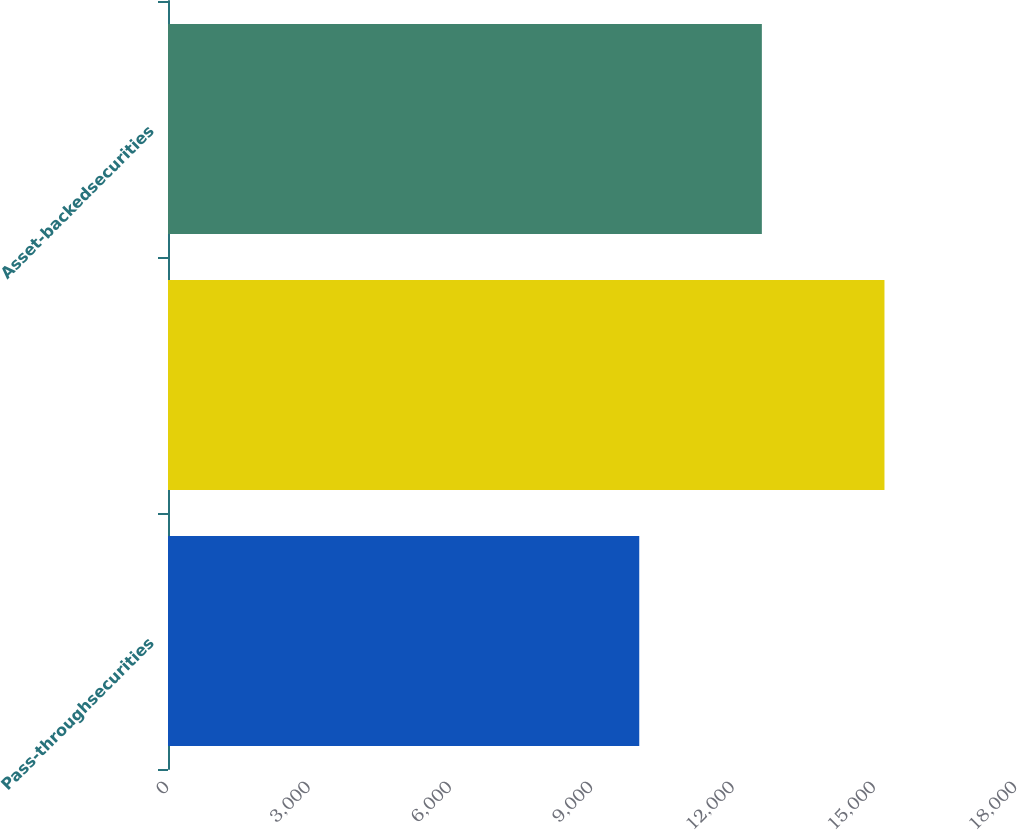Convert chart. <chart><loc_0><loc_0><loc_500><loc_500><bar_chart><fcel>Pass-throughsecurities<fcel>Unnamed: 1<fcel>Asset-backedsecurities<nl><fcel>10003<fcel>15208<fcel>12605.5<nl></chart> 